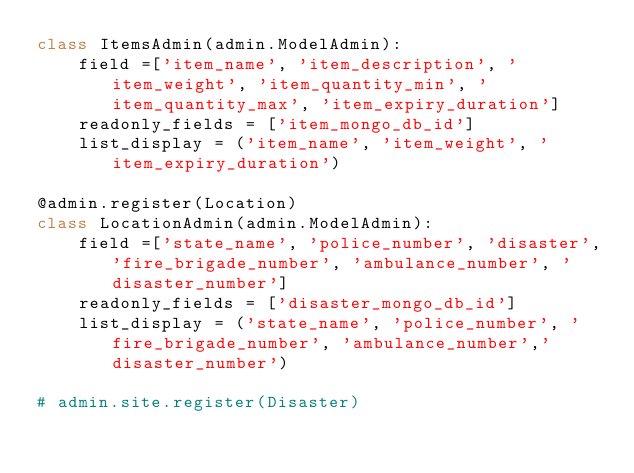<code> <loc_0><loc_0><loc_500><loc_500><_Python_>class ItemsAdmin(admin.ModelAdmin):
    field =['item_name', 'item_description', 'item_weight', 'item_quantity_min', 'item_quantity_max', 'item_expiry_duration']
    readonly_fields = ['item_mongo_db_id']
    list_display = ('item_name', 'item_weight', 'item_expiry_duration')

@admin.register(Location)
class LocationAdmin(admin.ModelAdmin):
    field =['state_name', 'police_number', 'disaster','fire_brigade_number', 'ambulance_number', 'disaster_number']
    readonly_fields = ['disaster_mongo_db_id']
    list_display = ('state_name', 'police_number', 'fire_brigade_number', 'ambulance_number','disaster_number')

# admin.site.register(Disaster)</code> 